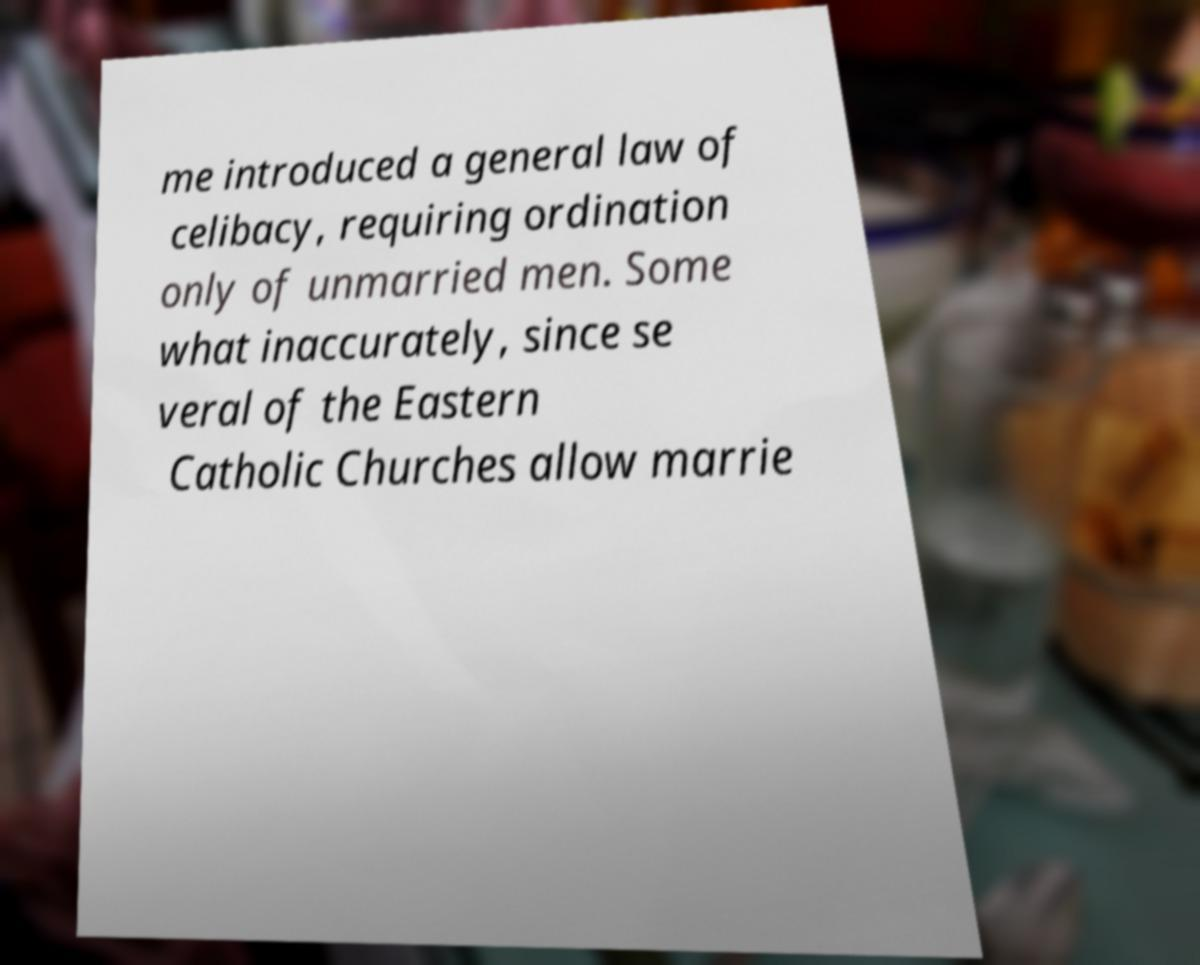Can you accurately transcribe the text from the provided image for me? me introduced a general law of celibacy, requiring ordination only of unmarried men. Some what inaccurately, since se veral of the Eastern Catholic Churches allow marrie 